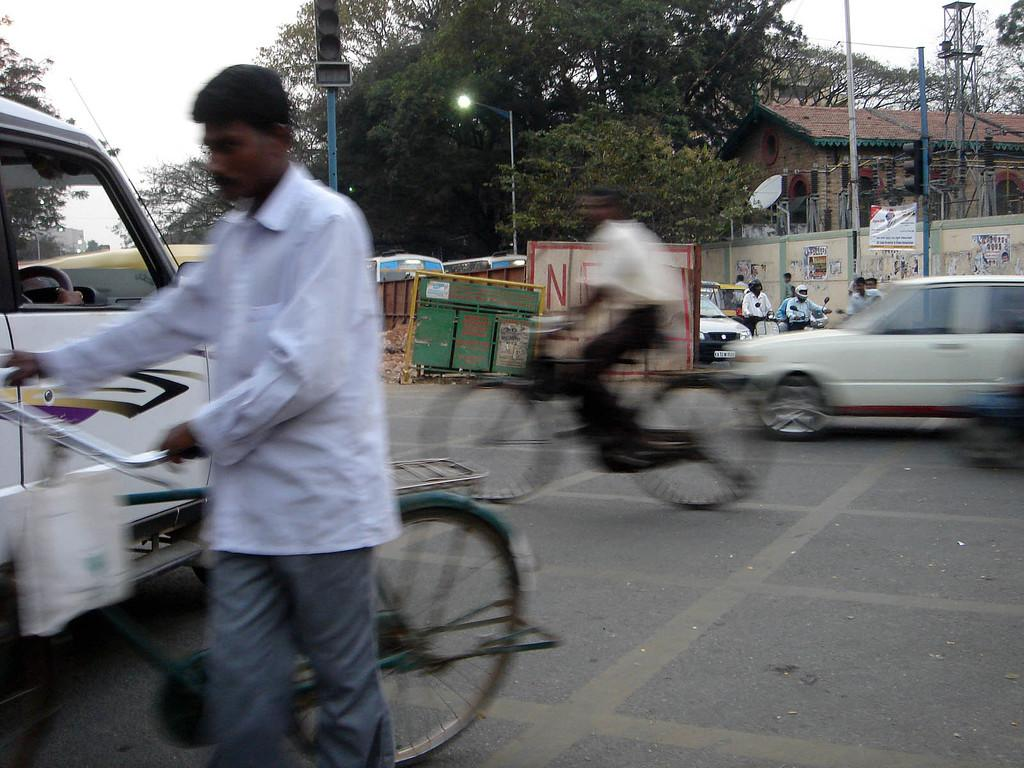Where was the image taken? The image is taken outdoors. What can be seen on the road in the image? There are two bicycles and vehicles on the road. What is present behind the vehicles? There is a light pole, trees, and a building in the background. What can be seen in the sky in the image? The sky is visible in the background. What traffic control device is present in the image? Traffic lights are present in the image. What type of ice can be seen melting on the bicycles in the image? There is no ice present on the bicycles in the image. What kind of mine is visible in the background of the image? There is no mine present in the image; it features a building in the background. 